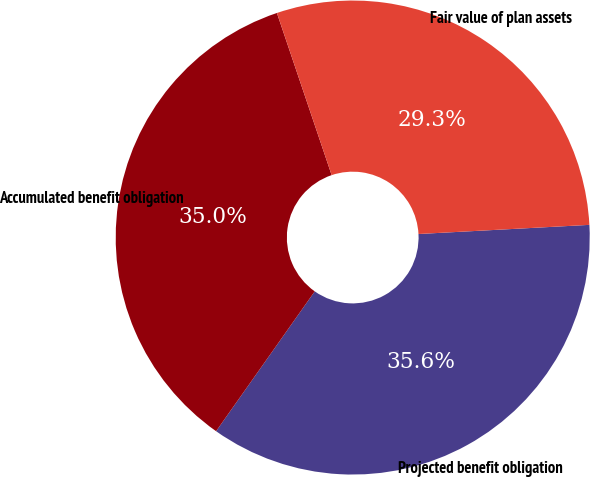Convert chart. <chart><loc_0><loc_0><loc_500><loc_500><pie_chart><fcel>Projected benefit obligation<fcel>Accumulated benefit obligation<fcel>Fair value of plan assets<nl><fcel>35.63%<fcel>35.04%<fcel>29.33%<nl></chart> 